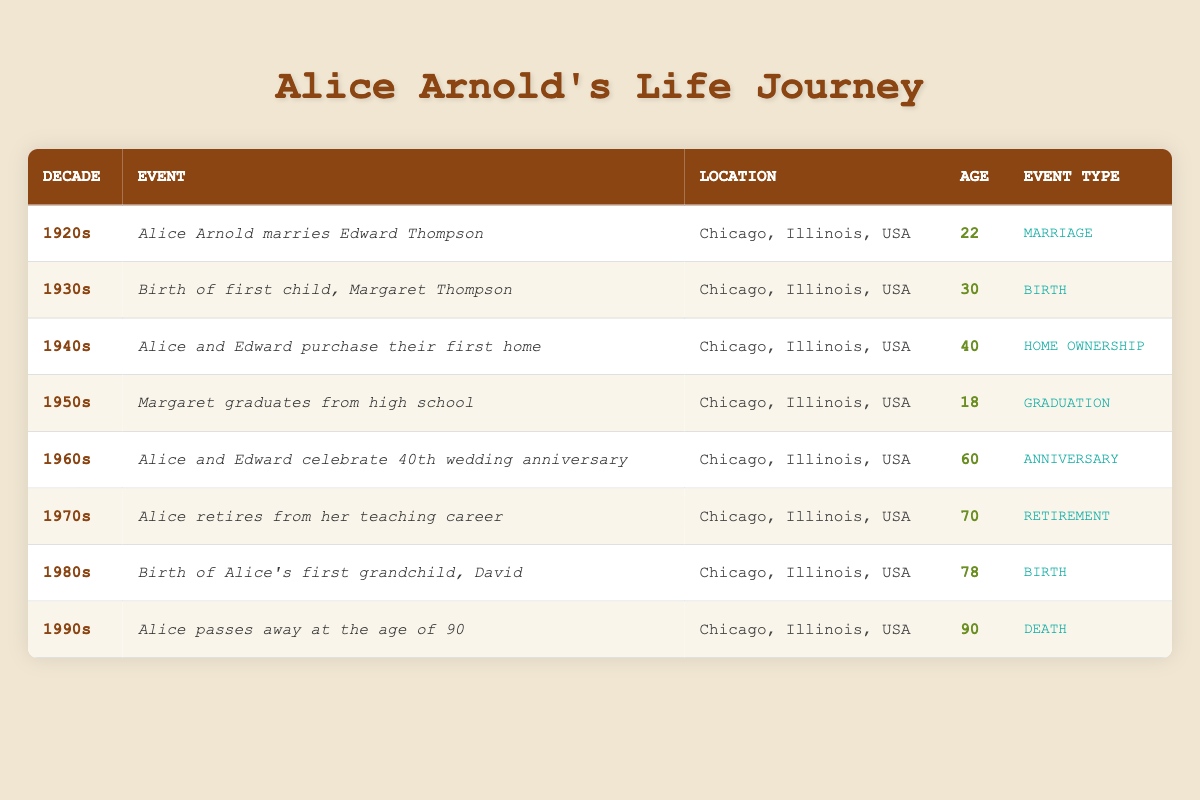What major life event happened for Alice Arnold in the 1920s? According to the table, Alice Arnold married Edward Thompson in the 1920s.
Answer: Alice Arnold marries Edward Thompson How old was Alice when she purchased her first home? The table states that Alice was 40 years old when she and Edward purchased their first home in the 1940s.
Answer: 40 Did Alice Arnold have any children? Yes, the table indicates that Alice had a child named Margaret Thompson, born in the 1930s.
Answer: Yes What event type was recorded for Alice in the 1960s? In the 1960s, the event recorded is their 40th wedding anniversary, classified as an Anniversary event type.
Answer: Anniversary What was the age difference between Alice when she retired and when her first grandchild was born? Alice was 70 when she retired (1970s) and 78 when her first grandchild was born (1980s). The difference is 78 - 70 = 8 years.
Answer: 8 years How many major life events are documented for Alice in the 1940s? The table lists one major life event for Alice in the 1940s, which is the purchase of their first home.
Answer: 1 In which decade did Alice celebrate her 40th wedding anniversary? The table shows that Alice and Edward celebrated their 40th wedding anniversary in the 1960s.
Answer: 1960s What was the last major life event recorded for Alice Arnold? The final event recorded for Alice is her passing in the 1990s, specifically stating that she passed away at the age of 90.
Answer: Her passing in the 1990s How many years apart did Alice’s children and grandchildren's births occur? Alice's first child, Margaret, was born in the 1930s, and her first grandchild, David, was born in the 1980s. The difference is 1980s - 1930s = 50 years.
Answer: 50 years Was Alice's marriage before or after the birth of her first child? According to the table, Alice married in the 1920s and had her first child in the 1930s. Thus, her marriage was before the birth of her first child.
Answer: Before 